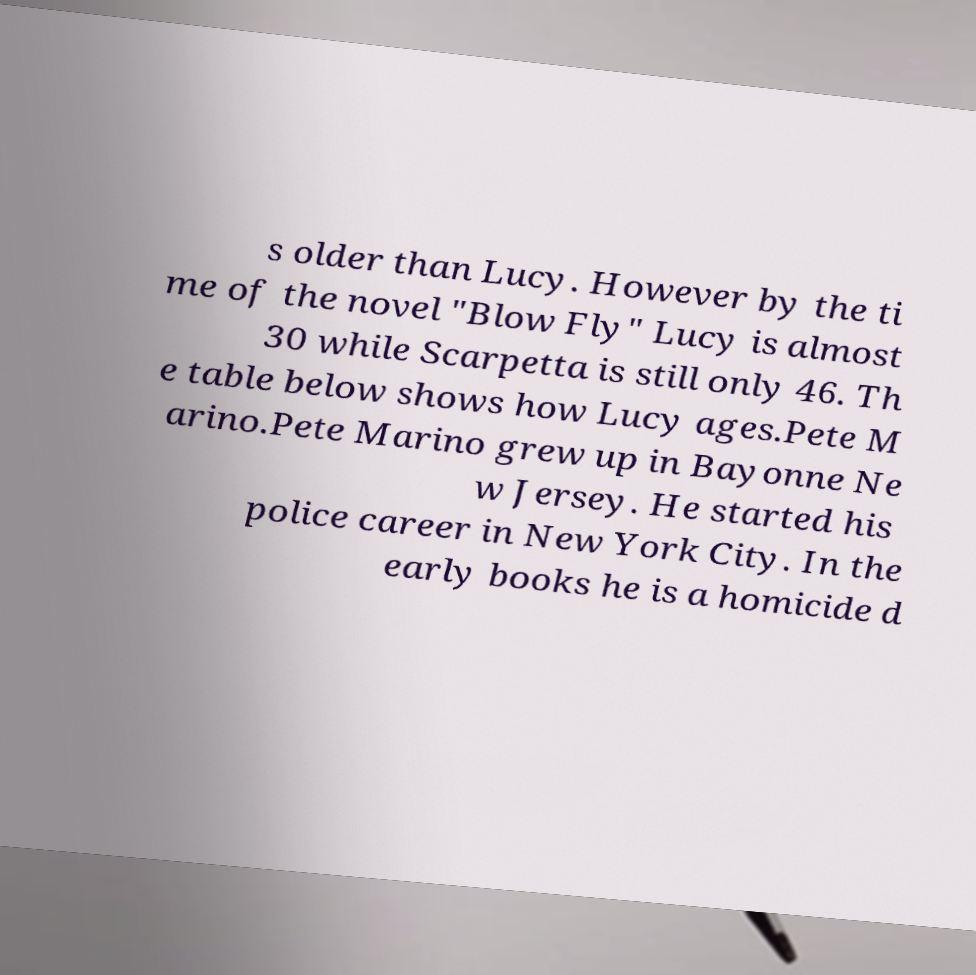Could you extract and type out the text from this image? s older than Lucy. However by the ti me of the novel "Blow Fly" Lucy is almost 30 while Scarpetta is still only 46. Th e table below shows how Lucy ages.Pete M arino.Pete Marino grew up in Bayonne Ne w Jersey. He started his police career in New York City. In the early books he is a homicide d 